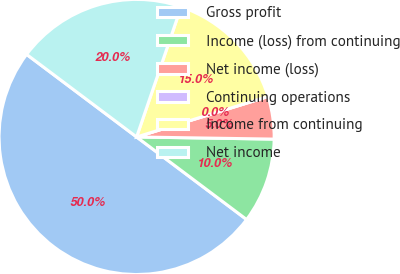<chart> <loc_0><loc_0><loc_500><loc_500><pie_chart><fcel>Gross profit<fcel>Income (loss) from continuing<fcel>Net income (loss)<fcel>Continuing operations<fcel>Income from continuing<fcel>Net income<nl><fcel>50.0%<fcel>10.0%<fcel>5.0%<fcel>0.0%<fcel>15.0%<fcel>20.0%<nl></chart> 